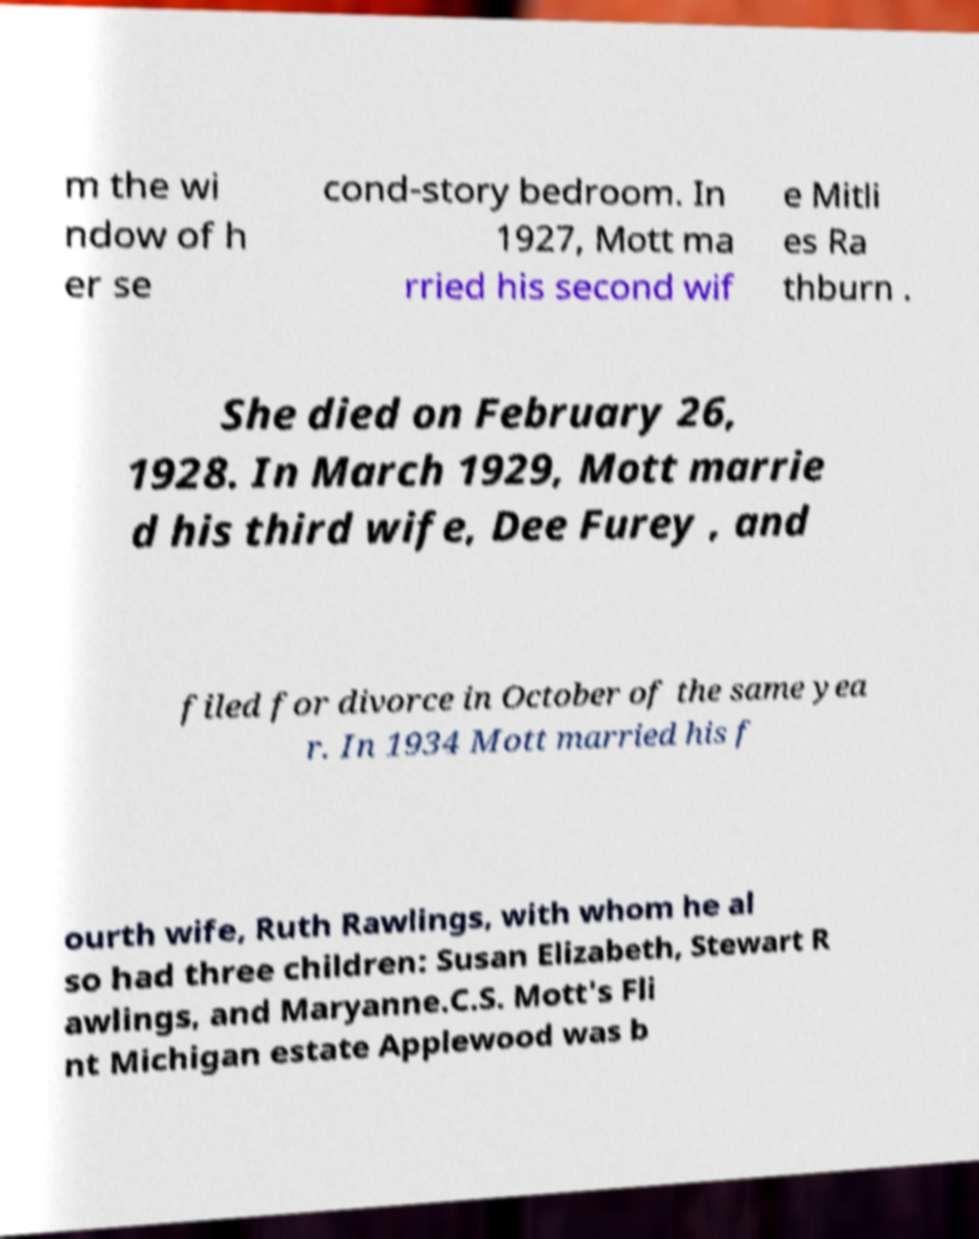Could you extract and type out the text from this image? m the wi ndow of h er se cond-story bedroom. In 1927, Mott ma rried his second wif e Mitli es Ra thburn . She died on February 26, 1928. In March 1929, Mott marrie d his third wife, Dee Furey , and filed for divorce in October of the same yea r. In 1934 Mott married his f ourth wife, Ruth Rawlings, with whom he al so had three children: Susan Elizabeth, Stewart R awlings, and Maryanne.C.S. Mott's Fli nt Michigan estate Applewood was b 